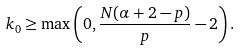Convert formula to latex. <formula><loc_0><loc_0><loc_500><loc_500>k _ { 0 } \geq \max \left ( 0 , \frac { N ( \alpha + 2 - p ) } { p } - 2 \right ) .</formula> 